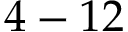<formula> <loc_0><loc_0><loc_500><loc_500>4 - 1 2</formula> 